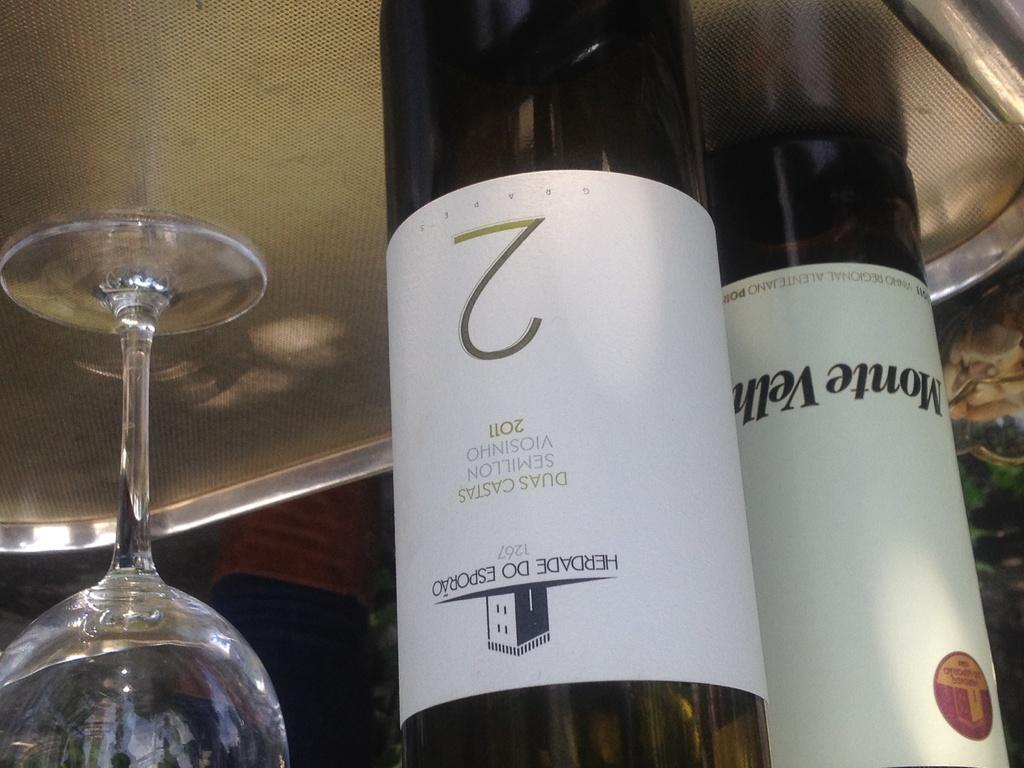<image>
Relay a brief, clear account of the picture shown. A wine bottle with a white label and a number 2 sits on a tray. 